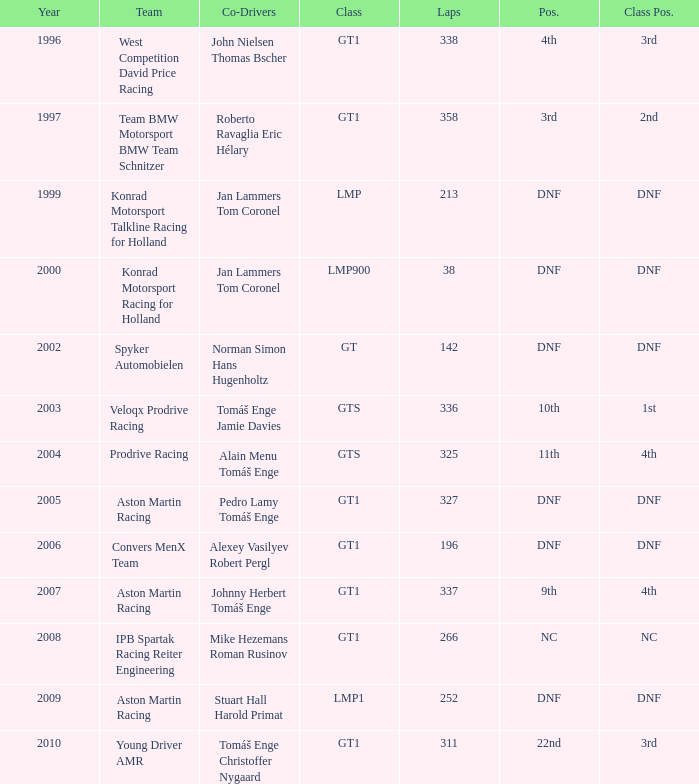Which placement ended 3rd in the class and accomplished fewer than 338 laps? 22nd. 